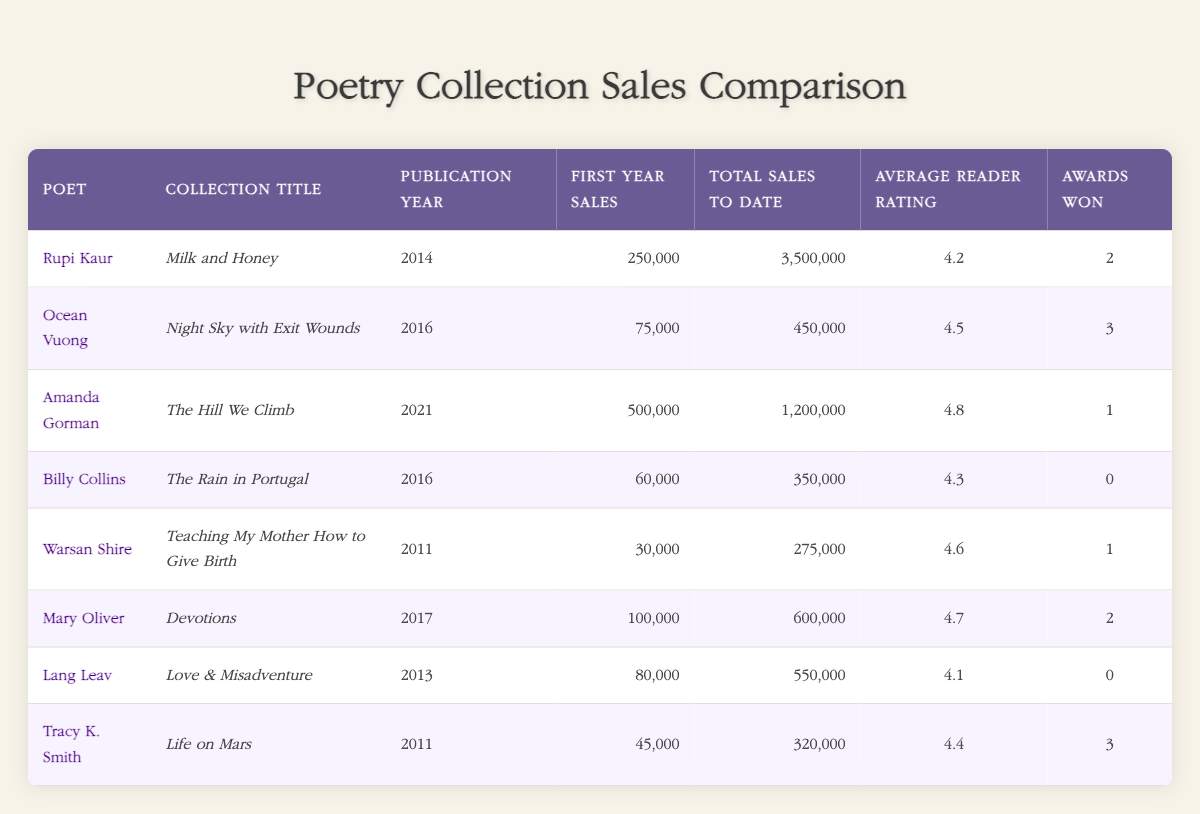What is the total sales figure for Rupi Kaur's collection? Rupi Kaur's collection "Milk and Honey" has a total sales figure of 3,500,000, as listed in the table. We refer directly to the relevant row and column for the total sales.
Answer: 3,500,000 Which poet has the highest average reader rating? Amanda Gorman's collection "The Hill We Climb" has the highest average reader rating of 4.8, compared to the ratings of other poets and their collections listed in the table. By comparing ratings across all poets, we find this value.
Answer: 4.8 How many awards did Lang Leav's collection win? Lang Leav's collection "Love & Misadventure" won 0 awards, as indicated in the relevant column of her row in the table. The answer is directly retrieved from this specific entry.
Answer: 0 What is the difference in total sales between Amanda Gorman's and Ocean Vuong's collections? Amanda Gorman's total sales are 1,200,000, and Ocean Vuong's total sales are 450,000. To find the difference, we subtract Ocean's sales from Amanda's: 1,200,000 - 450,000 = 750,000. This calculation combines information from both rows in the table.
Answer: 750,000 Is it true that Mary Oliver's collection has more first-year sales than Billy Collins's collection? Yes, Mary Oliver's "Devotions" has first-year sales of 100,000, while Billy Collins's "The Rain in Portugal" has first-year sales of 60,000. By comparing the first-year sales figures in the table, we confirm this is true.
Answer: Yes What is the average first-year sales across all collections? To find the average first-year sales, we sum the first-year sales figures: (250,000 + 75,000 + 500,000 + 60,000 + 30,000 + 100,000 + 80,000 + 45,000) = 1,140,000. There are 8 collections, so the average first-year sales are 1,140,000 / 8 = 142,500. This requires adding the first-year sales together and dividing by the number of collections.
Answer: 142,500 Who has won more awards, Tracy K. Smith or Warsan Shire? Tracy K. Smith has won 3 awards, whereas Warsan Shire has won 1 award. By comparing the "Awards Won" column in their respective rows, we see that Tracy has more.
Answer: Tracy K. Smith What collection was published in 2021? The collection published in 2021 is "The Hill We Climb" by Amanda Gorman. This information is found directly in the relevant row within the publication year column.
Answer: The Hill We Climb 